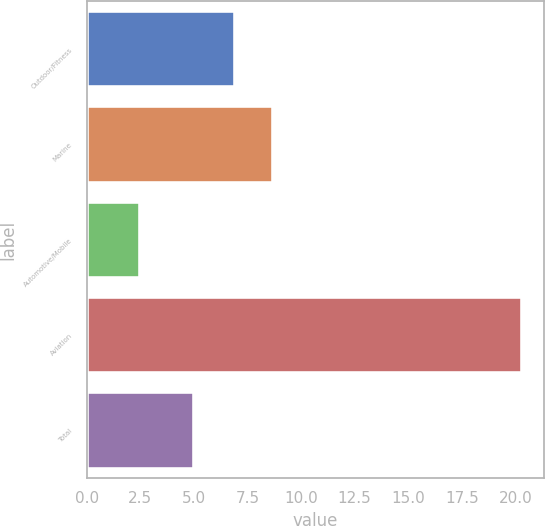<chart> <loc_0><loc_0><loc_500><loc_500><bar_chart><fcel>Outdoor/Fitness<fcel>Marine<fcel>Automotive/Mobile<fcel>Aviation<fcel>Total<nl><fcel>6.9<fcel>8.68<fcel>2.5<fcel>20.3<fcel>5<nl></chart> 